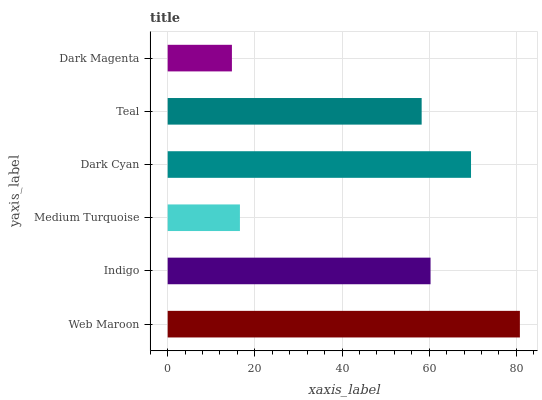Is Dark Magenta the minimum?
Answer yes or no. Yes. Is Web Maroon the maximum?
Answer yes or no. Yes. Is Indigo the minimum?
Answer yes or no. No. Is Indigo the maximum?
Answer yes or no. No. Is Web Maroon greater than Indigo?
Answer yes or no. Yes. Is Indigo less than Web Maroon?
Answer yes or no. Yes. Is Indigo greater than Web Maroon?
Answer yes or no. No. Is Web Maroon less than Indigo?
Answer yes or no. No. Is Indigo the high median?
Answer yes or no. Yes. Is Teal the low median?
Answer yes or no. Yes. Is Medium Turquoise the high median?
Answer yes or no. No. Is Indigo the low median?
Answer yes or no. No. 